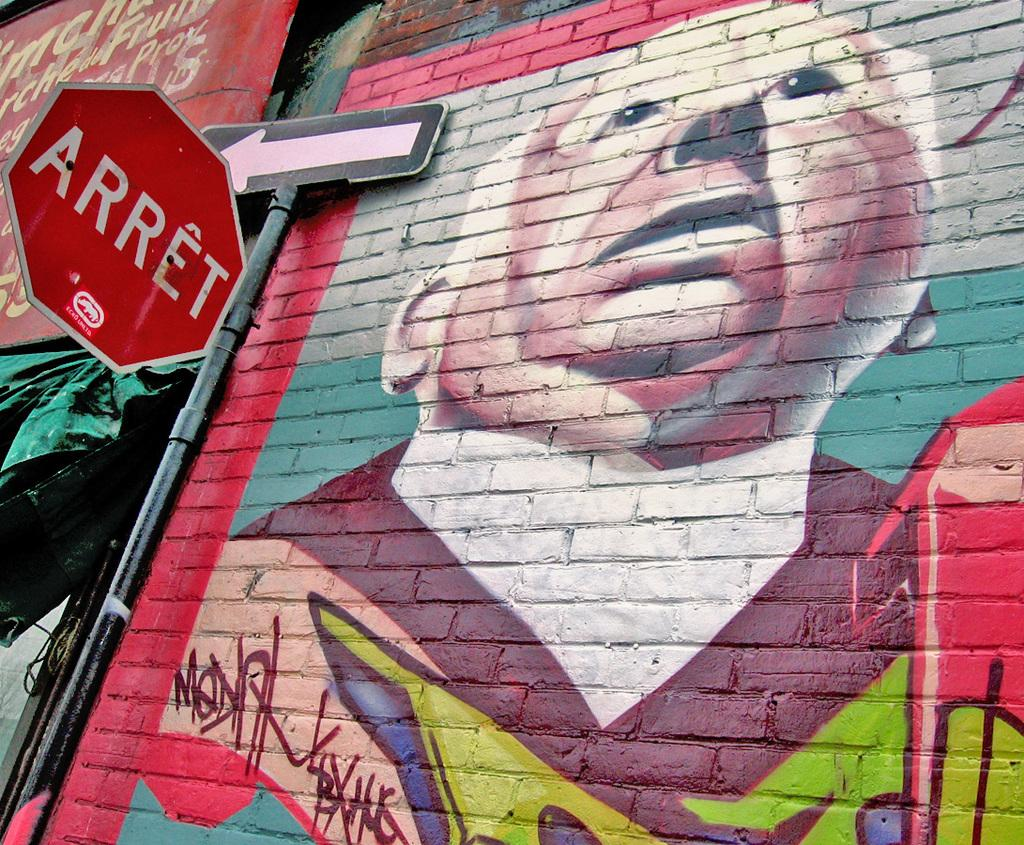<image>
Create a compact narrative representing the image presented. A brick wall has graffiti on it of a man and a red sign that says Arret. 